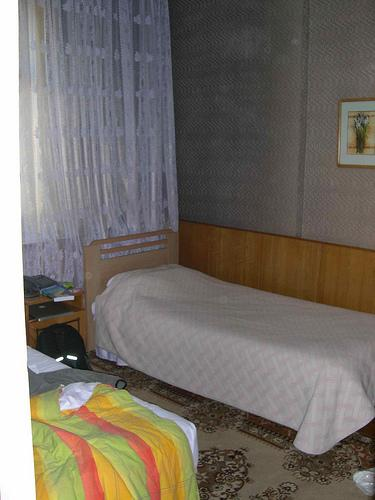Explain the sentimental aspect of this image. The image portrays a cozy and comforting atmosphere, with warm colors, soft beds, lace curtains, and captivating patterns on the rug and wallpaper. What are the main colors in the image and their corresponding objects? Various colors in the striped blankets, white for the lace curtains, black for the book bag and phone, brown for the wooden headboards, and mixed colors for the rug. What are the key elements in the image and their colors? There are twin beds with striped blankets in various colors, wooden headboards, a rug with a flowery design, white lace curtains, a portrait on the wall, and a bookbag on the floor. What are the two most prominent items in the scene? Two twin beds with striped blankets and wooden headboards are the most prominent items in the scene. Identify a reasoning task that can be performed using the details from the image. Determining the intended purpose of the room, which appears to be a bedroom designed for sleep and relaxation, based on the presence of twin beds, cozy blankets, and comforting decorations. Assess the image's quality in terms of lighting, resolution, and composition. The image has adequate lighting, high resolution, and a well-composed layout showcasing the main elements of the bedroom. Which objects in the image seem to be interacting with each other? The twin beds, with their blankets, headboards, and nearby nightstands, along with the rug, curtains, and wallpaper, create a cohesive whole in the bedroom. List the objects present in the room. Portrait, striped bedspreads, oriental carpet, long sheer white curtain, black book bag, book on nightstand, black phone, wooden headboard, twin beds, lace curtains, wooden stand, rug, wall paper, wood paneling, bed comforter, colorful comforter, and telephone. How many beds, blankets, and headboards can you count in the photo? There are 2 beds, 2 blankets, and 2 headboards in the photo. Tell me about the center of attention in this image. There are two twin beds positioned against the wall, with colorful striped blankets and wooden headboards, in a bedroom adorned with wallpaper and curtains. 